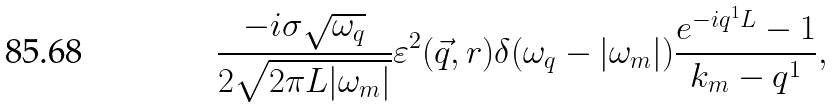<formula> <loc_0><loc_0><loc_500><loc_500>\frac { - i \sigma \sqrt { \omega _ { q } } } { 2 \sqrt { 2 \pi L | \omega _ { m } | } } \varepsilon ^ { 2 } ( \vec { q } , r ) \delta ( \omega _ { q } - | \omega _ { m } | ) \frac { e ^ { - i q ^ { 1 } L } - 1 } { k _ { m } - q ^ { 1 } } ,</formula> 